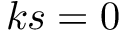<formula> <loc_0><loc_0><loc_500><loc_500>k s = 0</formula> 